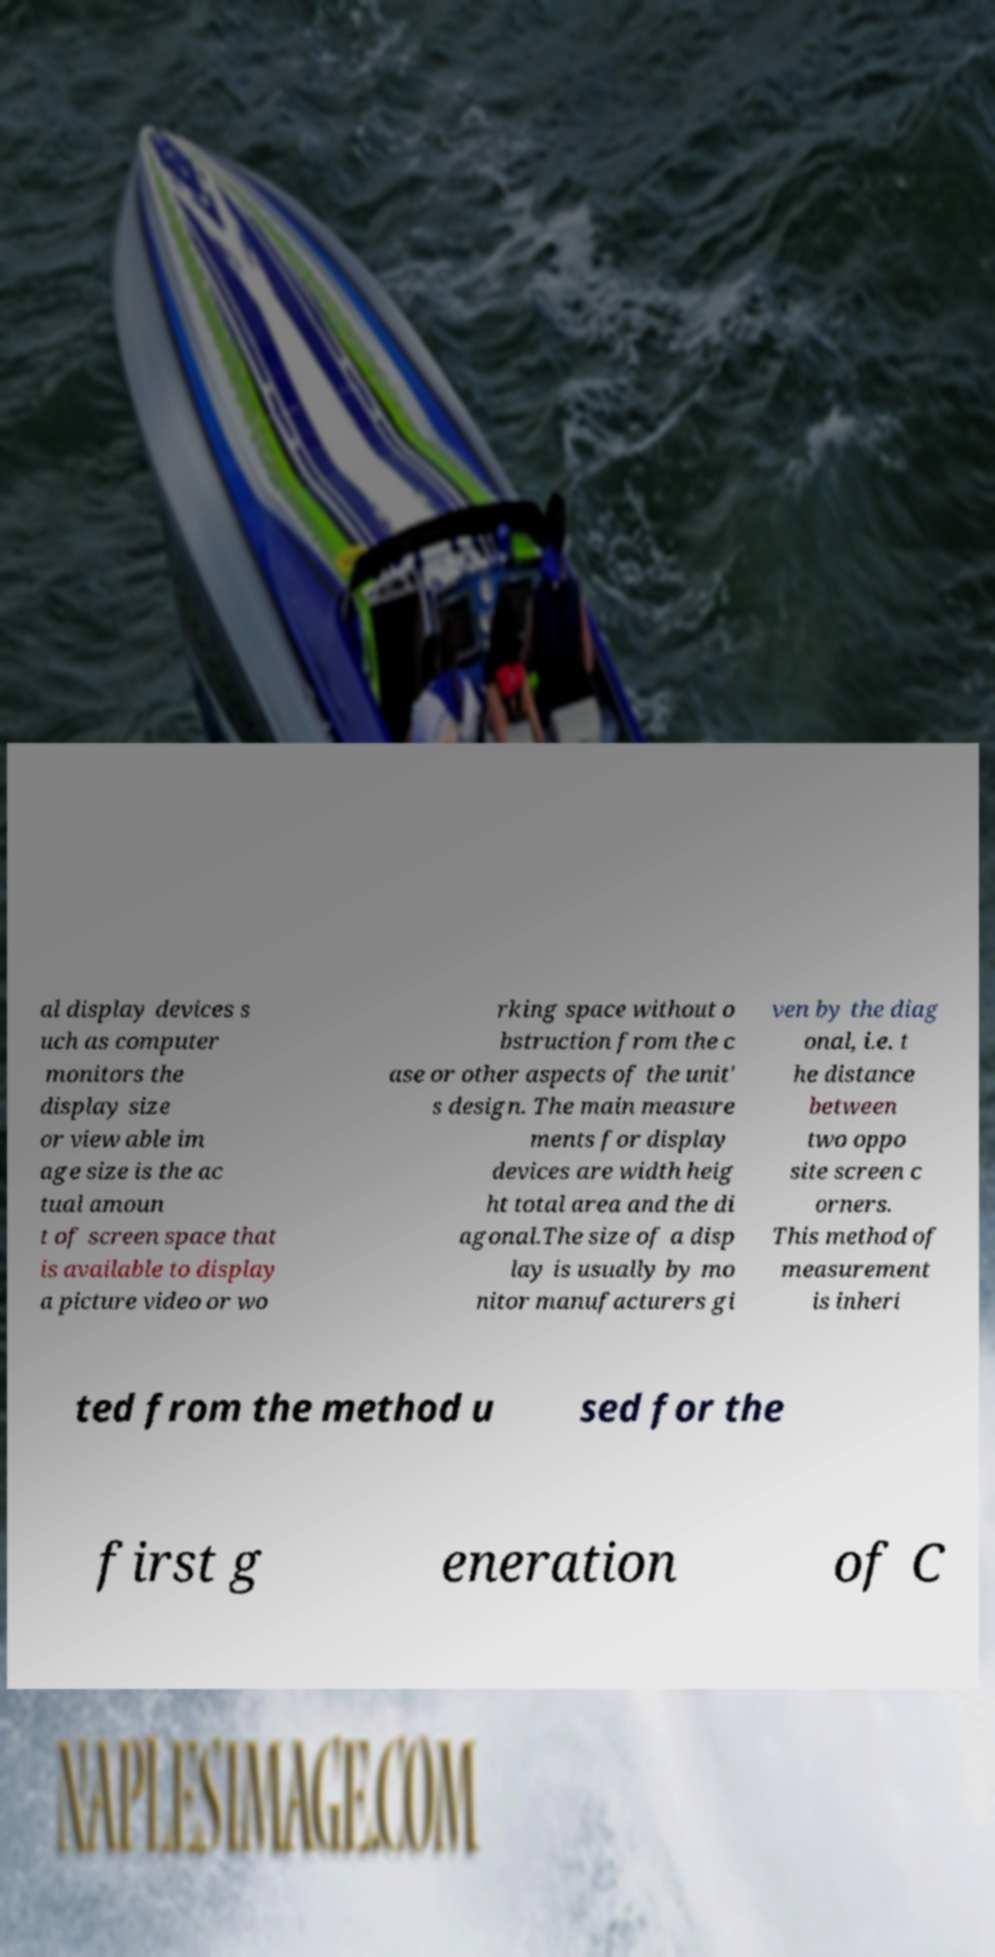What messages or text are displayed in this image? I need them in a readable, typed format. al display devices s uch as computer monitors the display size or view able im age size is the ac tual amoun t of screen space that is available to display a picture video or wo rking space without o bstruction from the c ase or other aspects of the unit' s design. The main measure ments for display devices are width heig ht total area and the di agonal.The size of a disp lay is usually by mo nitor manufacturers gi ven by the diag onal, i.e. t he distance between two oppo site screen c orners. This method of measurement is inheri ted from the method u sed for the first g eneration of C 